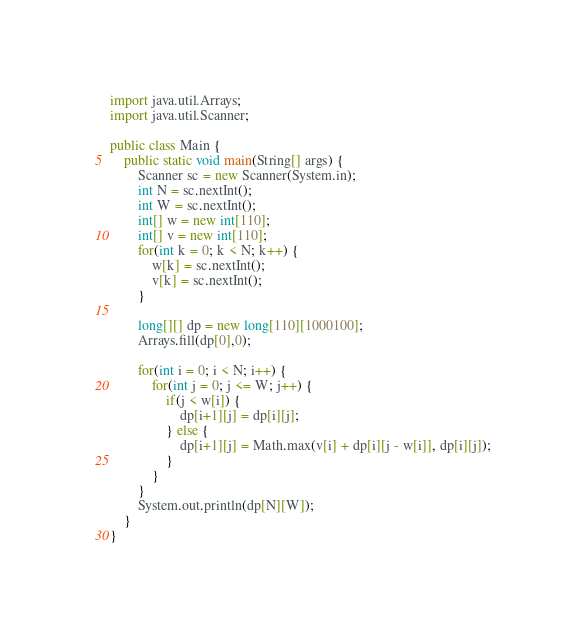Convert code to text. <code><loc_0><loc_0><loc_500><loc_500><_Java_>
import java.util.Arrays;
import java.util.Scanner;

public class Main {
    public static void main(String[] args) {
        Scanner sc = new Scanner(System.in);
        int N = sc.nextInt();
        int W = sc.nextInt();
        int[] w = new int[110];
        int[] v = new int[110];
        for(int k = 0; k < N; k++) {
            w[k] = sc.nextInt();
            v[k] = sc.nextInt();
        }

        long[][] dp = new long[110][1000100];
        Arrays.fill(dp[0],0);

        for(int i = 0; i < N; i++) {
            for(int j = 0; j <= W; j++) {
                if(j < w[i]) {
                    dp[i+1][j] = dp[i][j];
                } else {
                    dp[i+1][j] = Math.max(v[i] + dp[i][j - w[i]], dp[i][j]);
                }
            }
        }
        System.out.println(dp[N][W]);
    }
}
</code> 